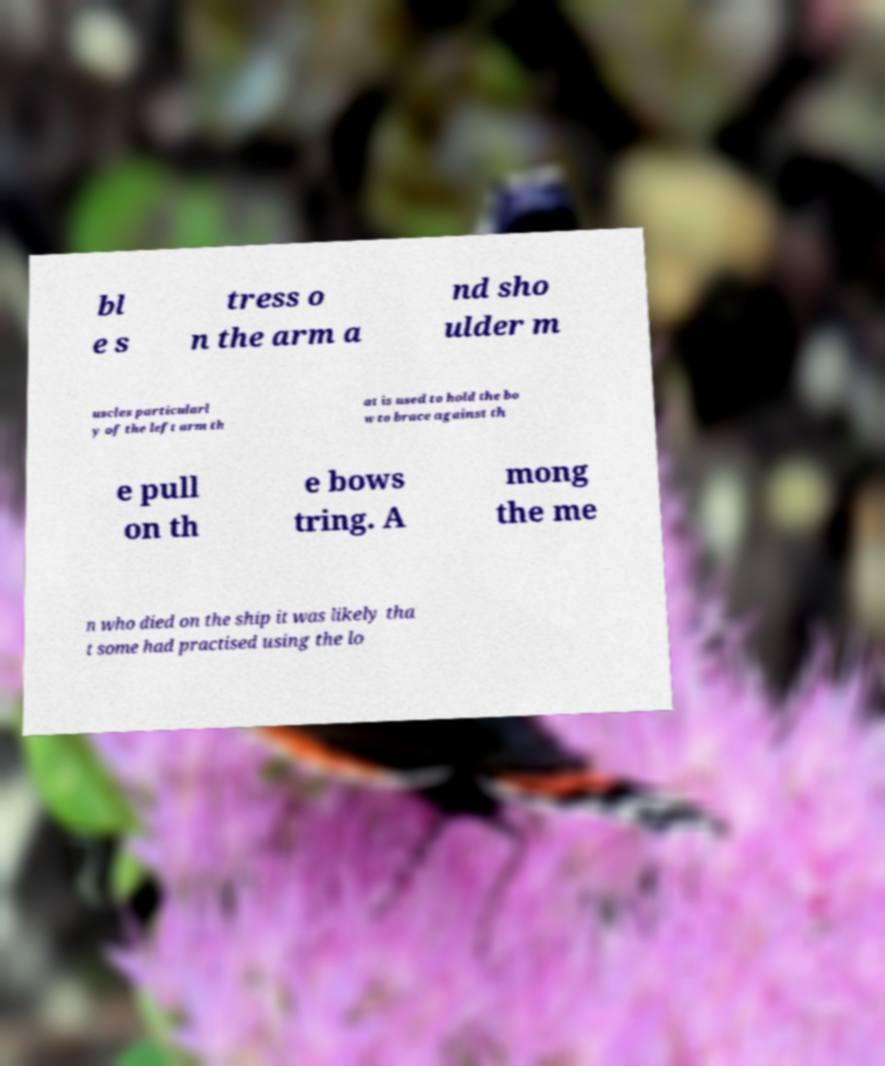There's text embedded in this image that I need extracted. Can you transcribe it verbatim? bl e s tress o n the arm a nd sho ulder m uscles particularl y of the left arm th at is used to hold the bo w to brace against th e pull on th e bows tring. A mong the me n who died on the ship it was likely tha t some had practised using the lo 